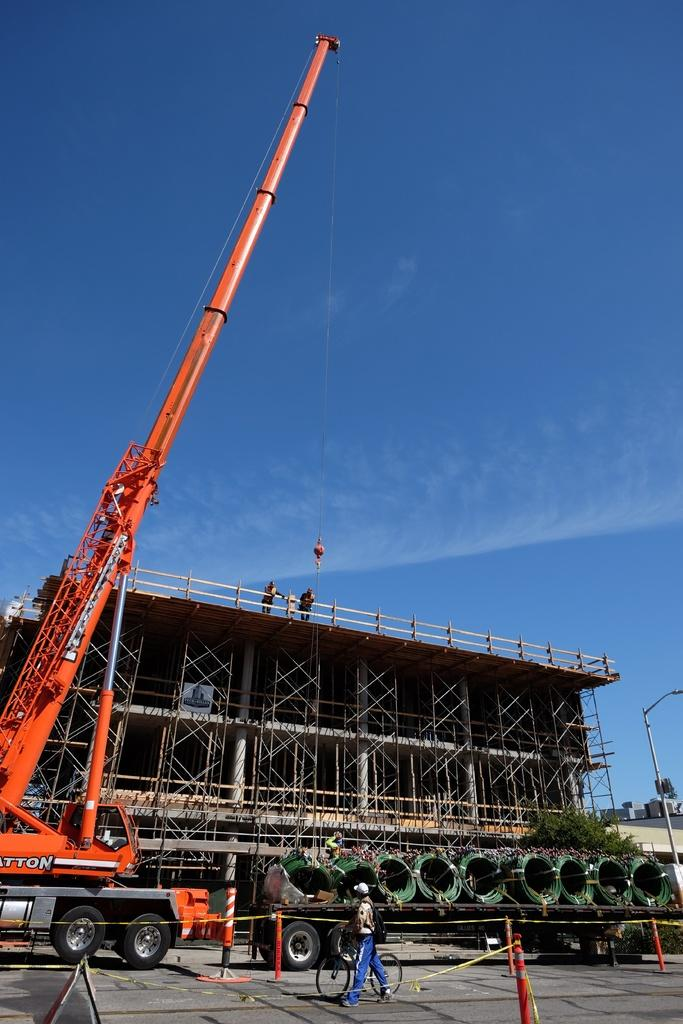What is the person in the image doing? The person in the image is walking on the road. What is located near the person? There is a vehicle beside the person. What type of structure can be seen in the image? There is a construction building in the image. Where are the balls located in the image? There are no balls present in the image. What type of farm can be seen in the image? There is no farm present in the image. 